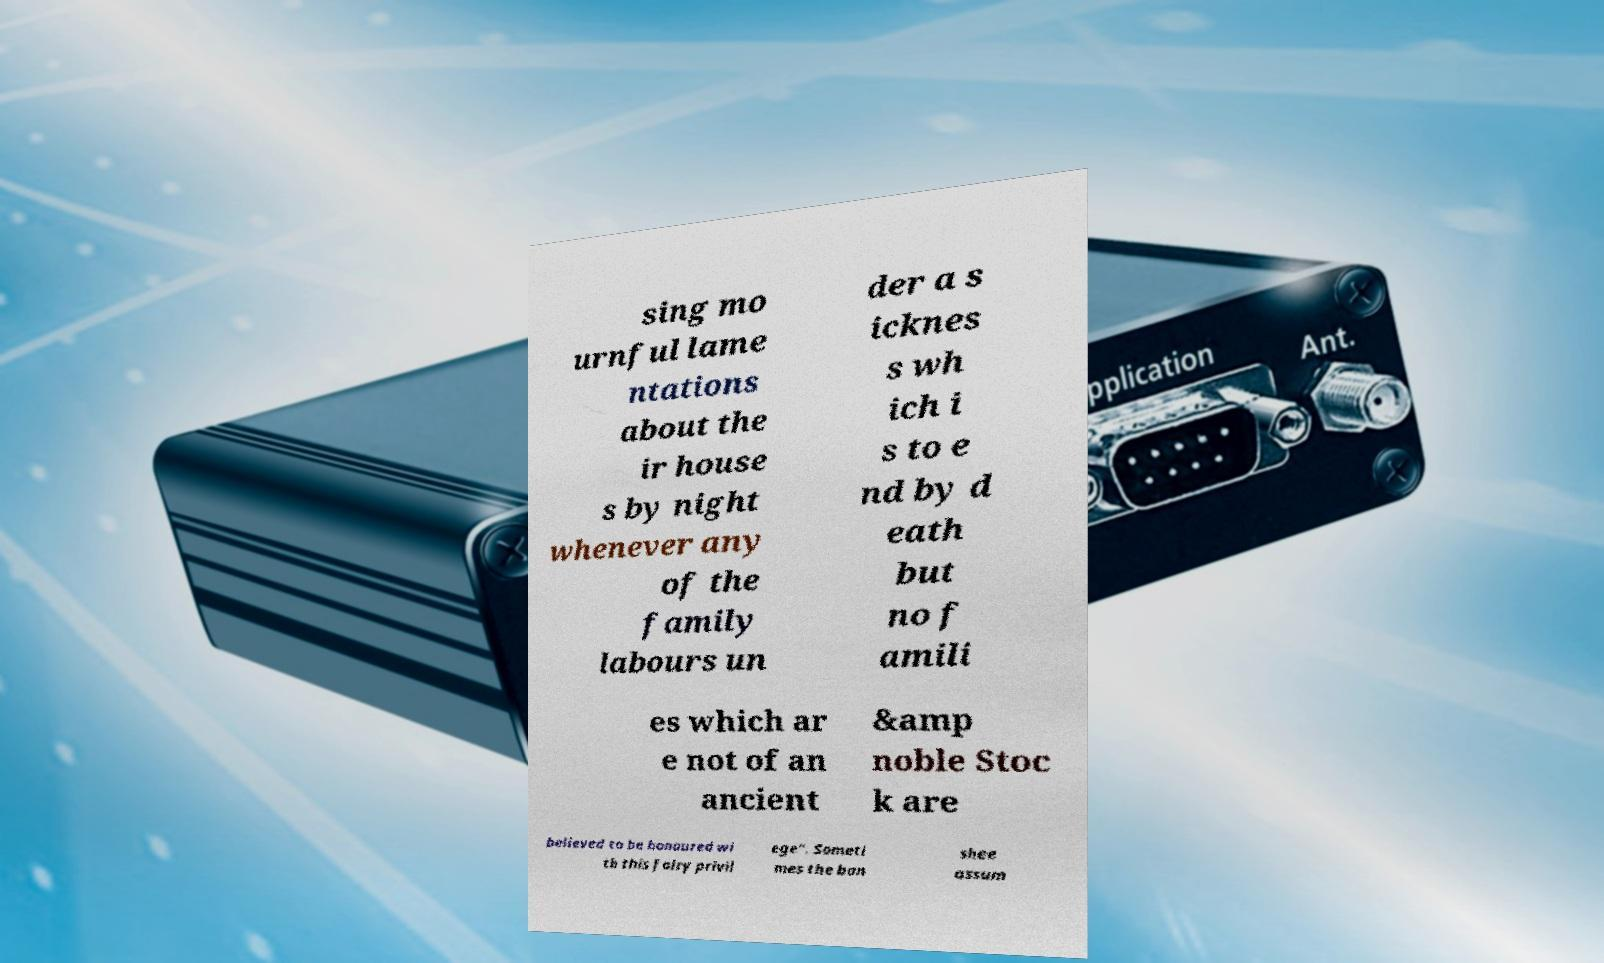Please identify and transcribe the text found in this image. sing mo urnful lame ntations about the ir house s by night whenever any of the family labours un der a s icknes s wh ich i s to e nd by d eath but no f amili es which ar e not of an ancient &amp noble Stoc k are believed to be honoured wi th this fairy privil ege". Someti mes the ban shee assum 